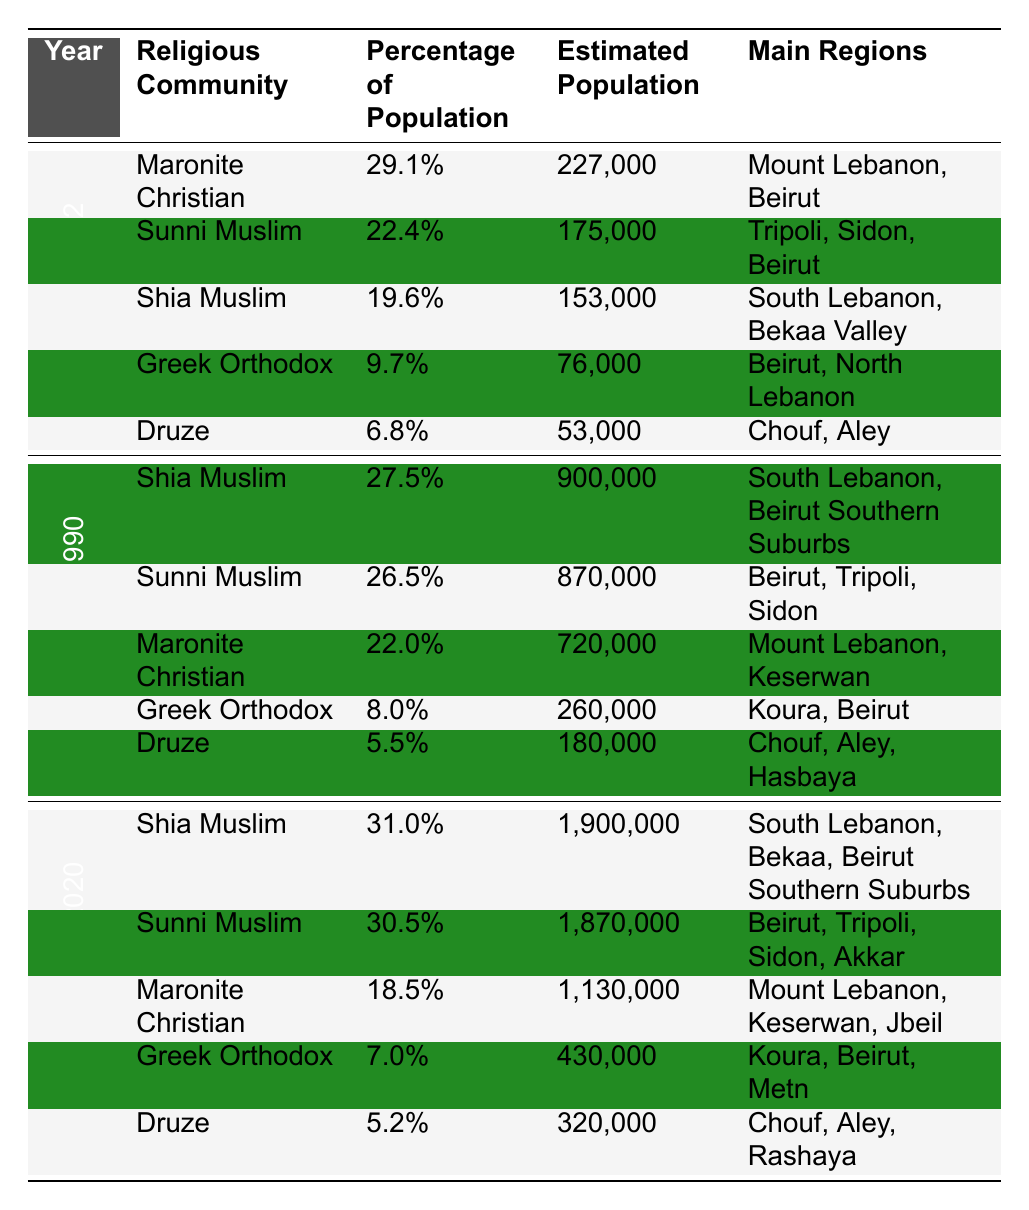What was the estimated population of Maronite Christians in 1932? In the year 1932, the estimated population of Maronite Christians is given directly in the table as 227,000.
Answer: 227,000 What percentage of the population did Shia Muslims represent in 1990? According to the table, Shia Muslims made up 27.5% of the population in 1990.
Answer: 27.5% What was the total estimated population of the three largest communities in 2020? In 2020, the estimated populations are Shia Muslims (1,900,000), Sunni Muslims (1,870,000), and Maronite Christians (1,130,000). Summing these gives 1,900,000 + 1,870,000 + 1,130,000 = 4,900,000.
Answer: 4,900,000 Which religious community experienced the largest percentage increase from 1932 to 1990? The percentage of Shia Muslims increased from 19.6% in 1932 to 27.5% in 1990, a difference of 7.9%. Sunni Muslims also increased from 22.4% to 26.5%, which is a difference of 4.1%. Maronite Christians decreased from 29.1% to 22.0%, while Greek Orthodox and Druze also decreased. The largest increase is therefore for Shia Muslims.
Answer: Shia Muslims Did the percentage of Maronite Christians decrease from 1990 to 2020? In 1990, Maronite Christians constituted 22.0% of the population, but by 2020, their percentage dropped to 18.5%. Thus, the percentage did decrease.
Answer: Yes What was the difference in estimated population of Sunni Muslims between 1990 and 2020? In 1990, Sunni Muslims had an estimated population of 870,000, and in 2020, it increased to 1,870,000. The difference is 1,870,000 - 870,000 = 1,000,000.
Answer: 1,000,000 Which community had the least estimated population in 1932? The table shows that the Druze had the least estimated population in 1932 with 53,000.
Answer: Druze What community showed the largest population decrease percentage-wise from 1932 to 2020? The Maronite Christians: in 1932 they were 29.1% and in 2020 they became 18.5%, a percentage decrease of 10.6%. The Greek Orthodox also decreased from 9.7% to 7.0%. Calculating gives an effective decrease of 10.6% for Maronites and 2.7% for Orthodox. The largest population decline percentage-wise is for Maronite Christians.
Answer: Maronite Christians What is the percentage of Greek Orthodox in 1990 compared to their percentage in 2020? The Greeks Orthodox constituted 8.0% in 1990 and decreased to 7.0% in 2020. The difference is 1.0%.
Answer: Decreased by 1.0% How many estimated Shia Muslims were there in 2020 compared to 1990? In 2020, there were 1,900,000 estimated Shia Muslims while in 1990 there were 900,000. The difference is 1,900,000 - 900,000 = 1,000,000.
Answer: 1,000,000 Which religious community has been consistently decreasing in percentage from 1932 to 2020? By analyzing the table, Maronite Christians decreased from 29.1% to 22.0% in 1990, and further decreased to 18.5% in 2020, showing a consistent decrease in percentage.
Answer: Maronite Christians 